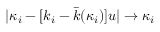<formula> <loc_0><loc_0><loc_500><loc_500>| \kappa _ { i } - [ k _ { i } - \bar { k } ( \kappa _ { i } ) ] u | \rightarrow \kappa _ { i }</formula> 